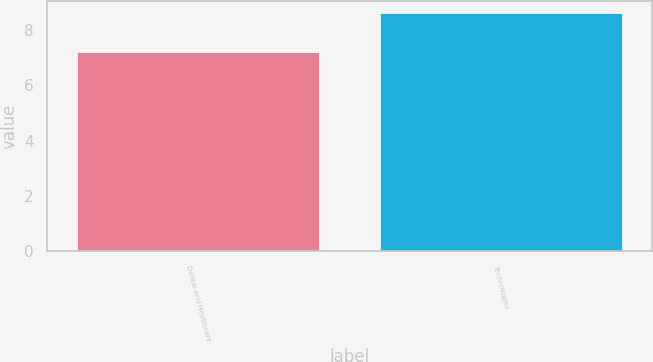Convert chart to OTSL. <chart><loc_0><loc_0><loc_500><loc_500><bar_chart><fcel>Dental and Healthcare<fcel>Technologies<nl><fcel>7.2<fcel>8.6<nl></chart> 